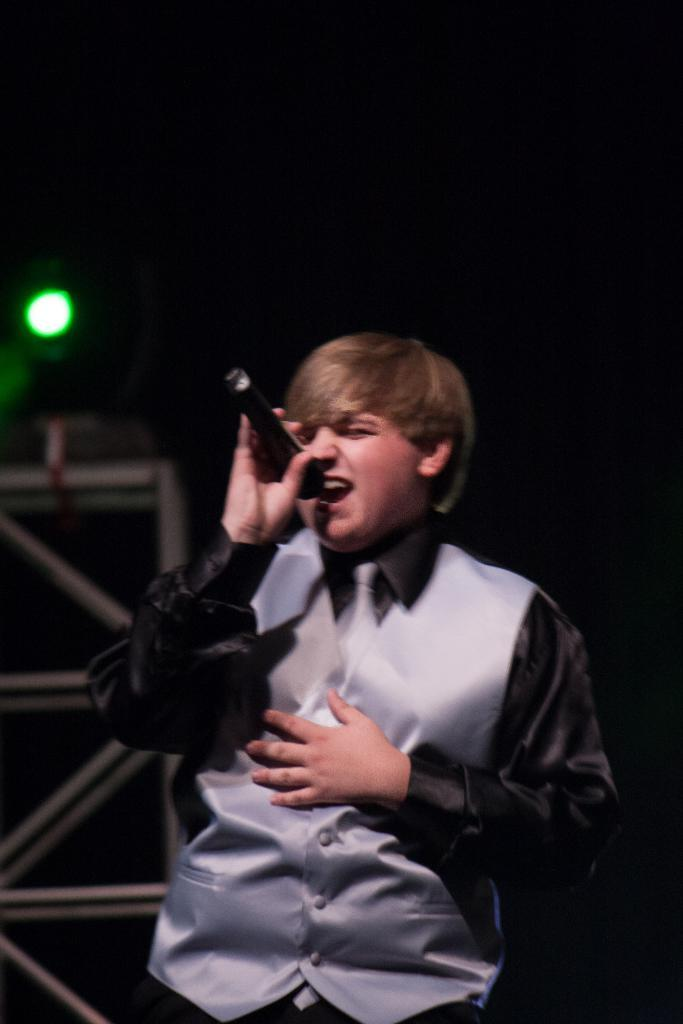Who is the main subject in the image? There is a boy in the image. What is the boy wearing? The boy is wearing a silver and black suit. What is the boy holding in the image? The boy is holding a microphone. What is the boy doing in the image? The boy is singing a song. What color is the light behind the boy? There is a green light behind the boy. What type of art can be seen on the hill in the background of the image? There is no hill or art present in the image; it features a boy singing with a green light behind him. 